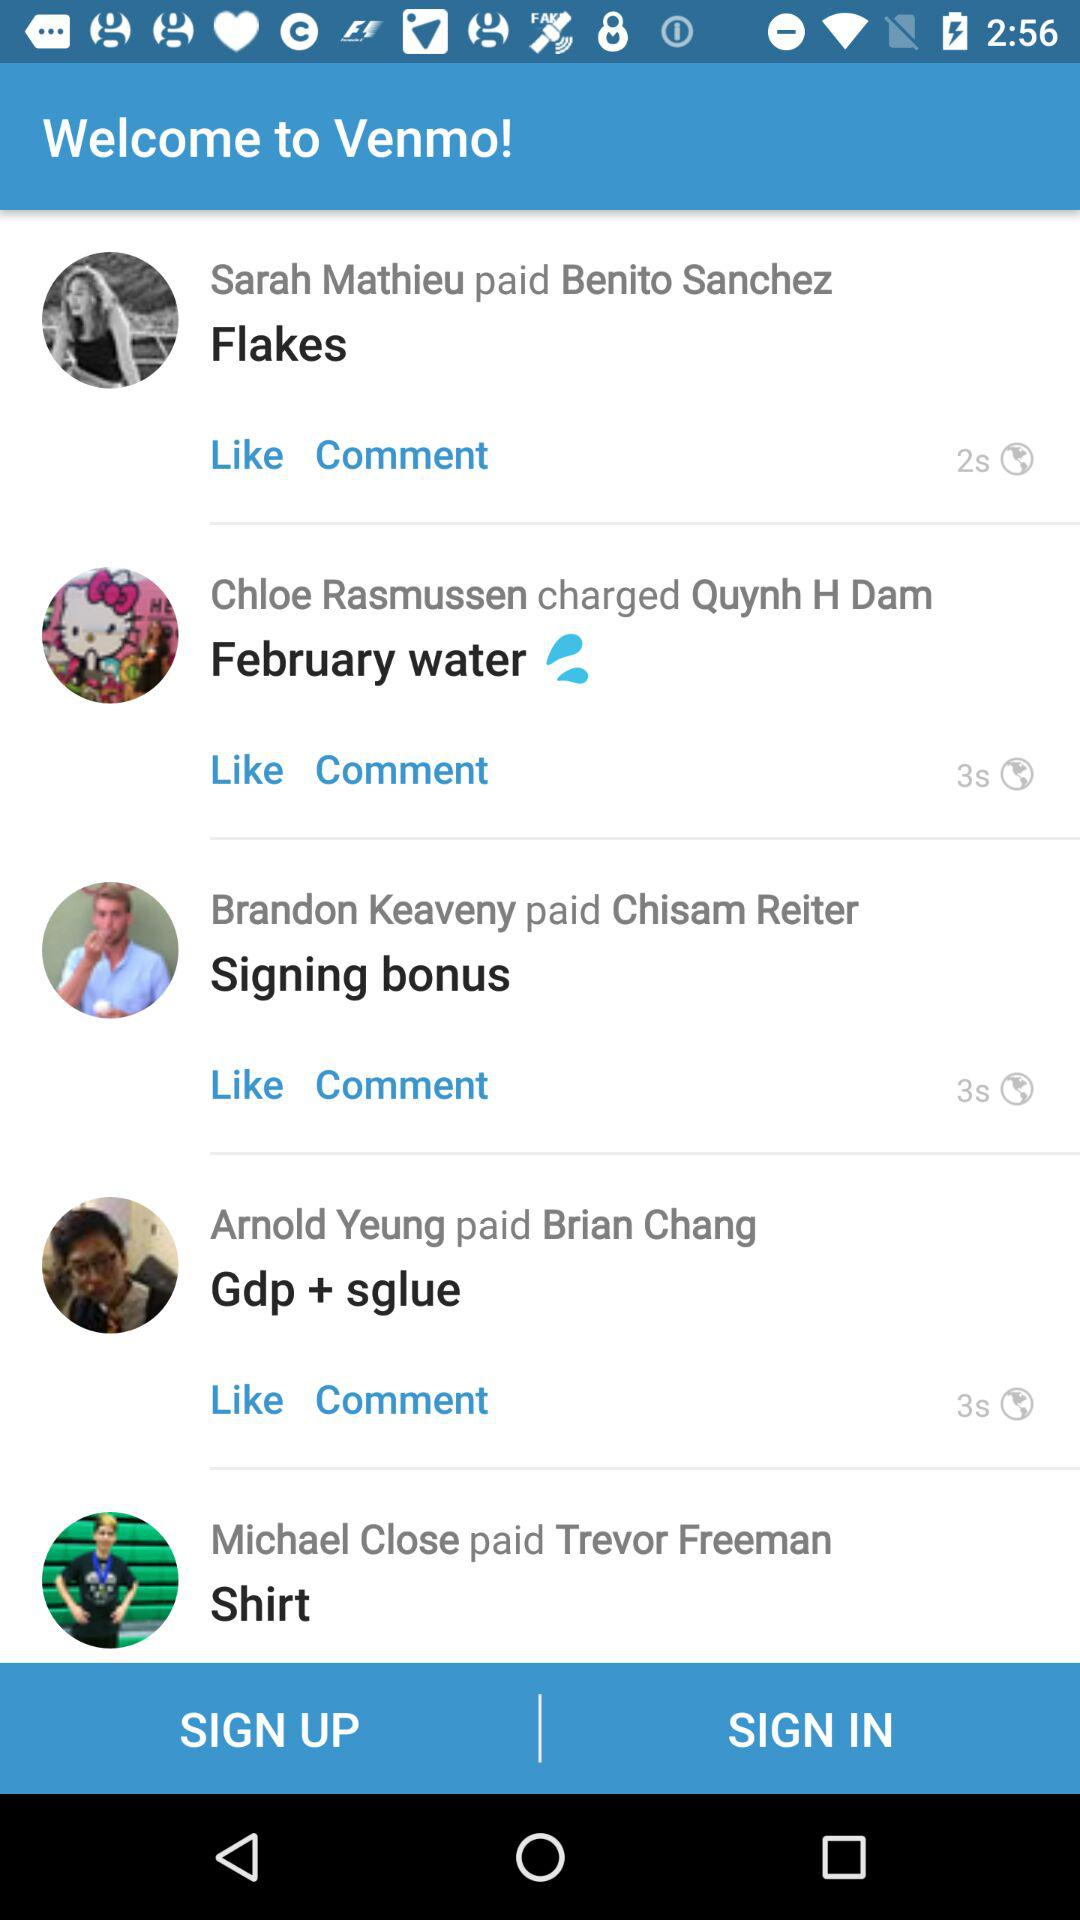Who paid Benito Sanchez? Benito Sanchez was paid by Sarah Mathieu. 